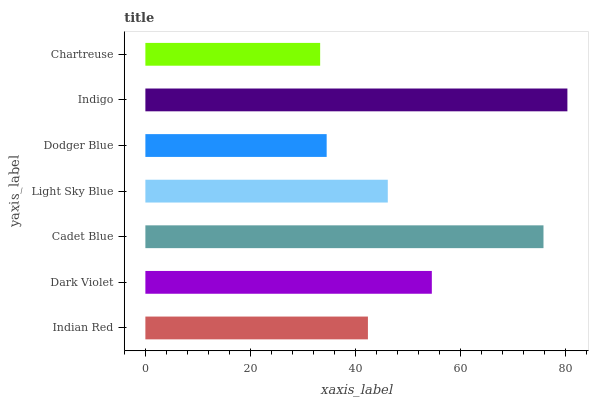Is Chartreuse the minimum?
Answer yes or no. Yes. Is Indigo the maximum?
Answer yes or no. Yes. Is Dark Violet the minimum?
Answer yes or no. No. Is Dark Violet the maximum?
Answer yes or no. No. Is Dark Violet greater than Indian Red?
Answer yes or no. Yes. Is Indian Red less than Dark Violet?
Answer yes or no. Yes. Is Indian Red greater than Dark Violet?
Answer yes or no. No. Is Dark Violet less than Indian Red?
Answer yes or no. No. Is Light Sky Blue the high median?
Answer yes or no. Yes. Is Light Sky Blue the low median?
Answer yes or no. Yes. Is Indian Red the high median?
Answer yes or no. No. Is Indian Red the low median?
Answer yes or no. No. 